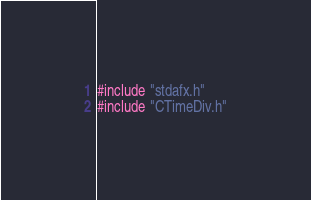Convert code to text. <code><loc_0><loc_0><loc_500><loc_500><_ObjectiveC_>#include "stdafx.h"
#include "CTimeDiv.h"
</code> 